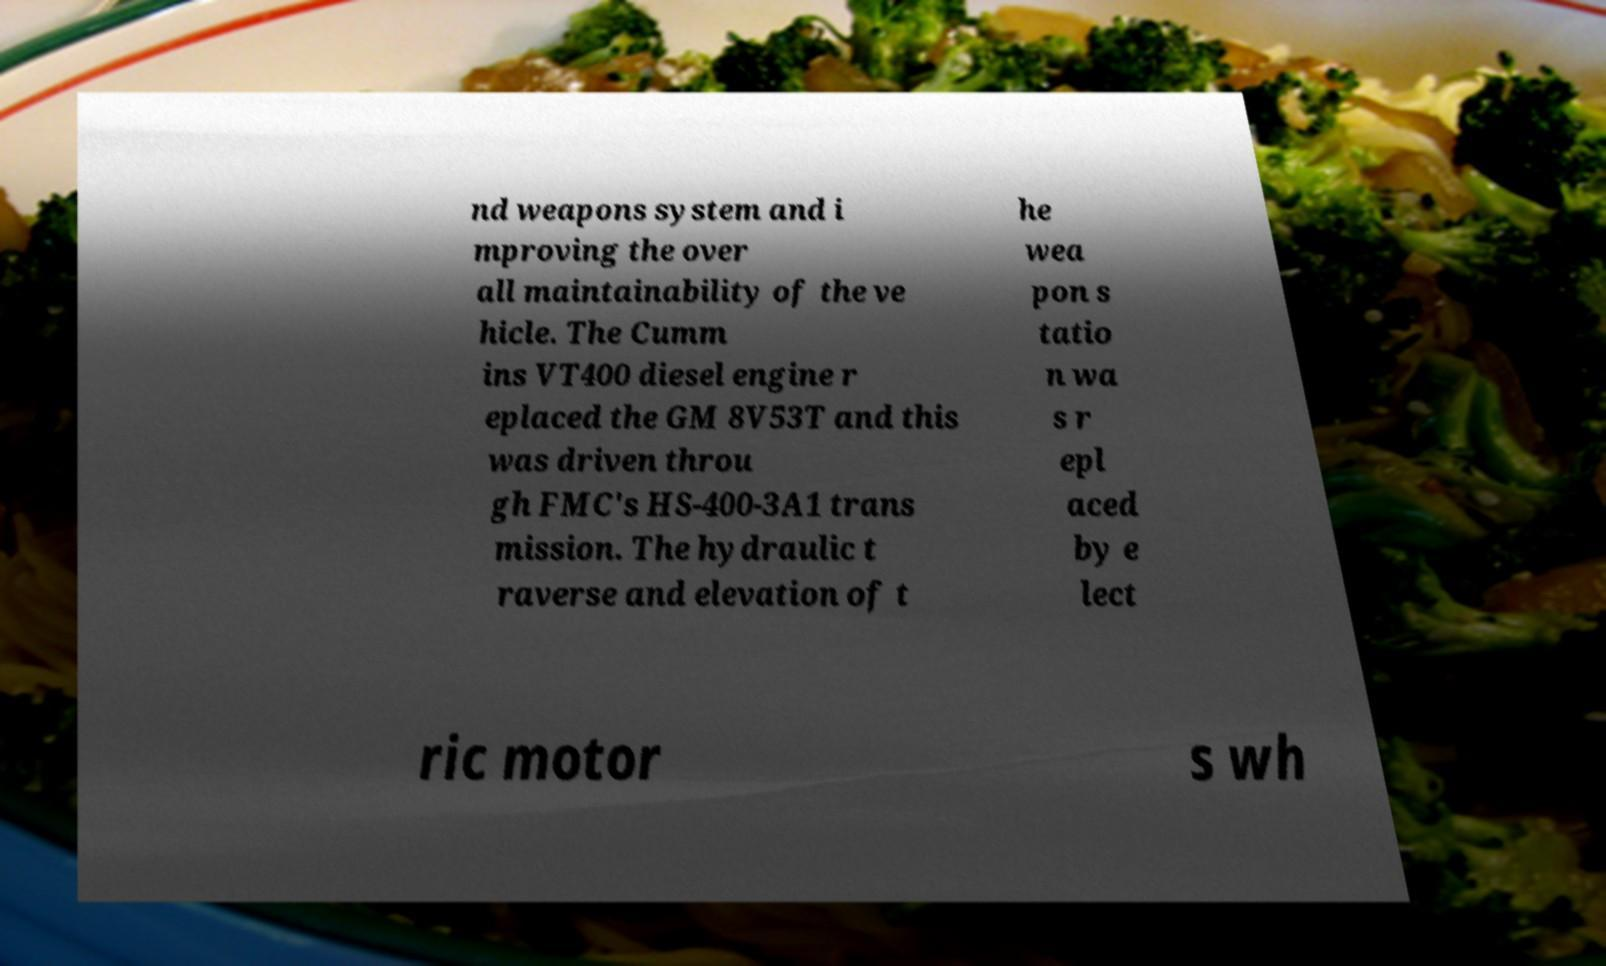Could you assist in decoding the text presented in this image and type it out clearly? nd weapons system and i mproving the over all maintainability of the ve hicle. The Cumm ins VT400 diesel engine r eplaced the GM 8V53T and this was driven throu gh FMC's HS-400-3A1 trans mission. The hydraulic t raverse and elevation of t he wea pon s tatio n wa s r epl aced by e lect ric motor s wh 